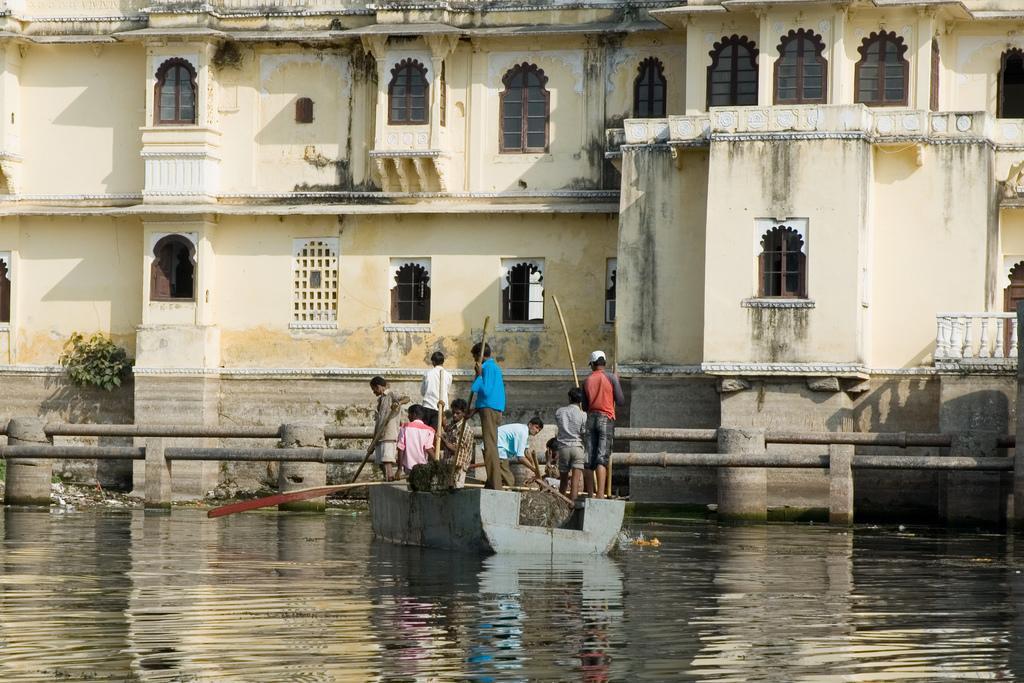How would you summarize this image in a sentence or two? In this image I can see a white colour building, number of windows, water and in it I can see a boat. I can also see number of people over here and I can see few of them are holding sticks. Over there I can see number of leaves. 